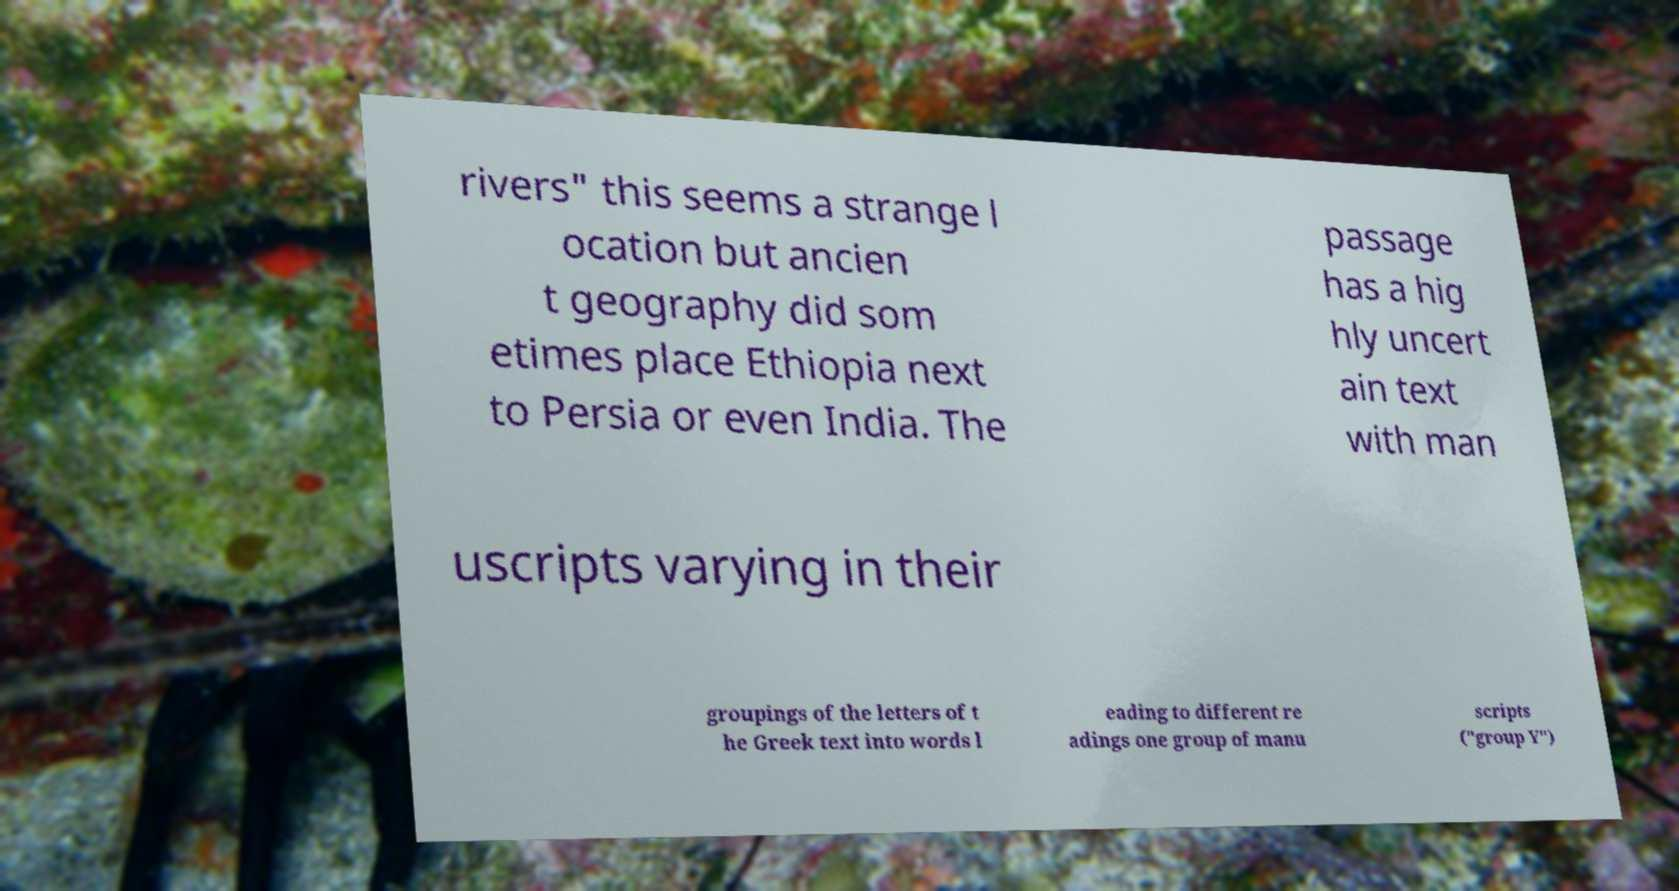Can you read and provide the text displayed in the image?This photo seems to have some interesting text. Can you extract and type it out for me? rivers" this seems a strange l ocation but ancien t geography did som etimes place Ethiopia next to Persia or even India. The passage has a hig hly uncert ain text with man uscripts varying in their groupings of the letters of t he Greek text into words l eading to different re adings one group of manu scripts ("group Y") 